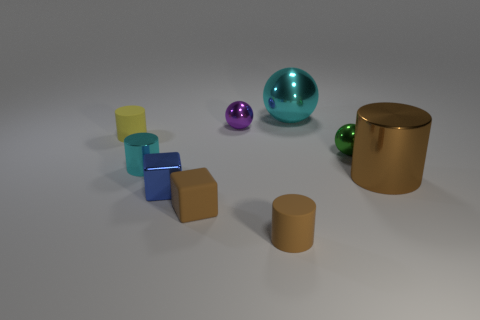How big is the brown rubber thing to the right of the brown rubber object that is on the left side of the brown cylinder on the left side of the large metallic cylinder?
Your answer should be very brief. Small. Is the number of big spheres that are to the right of the tiny green thing less than the number of cyan spheres that are to the right of the metallic block?
Ensure brevity in your answer.  Yes. How many green balls are the same material as the big cyan ball?
Provide a short and direct response. 1. There is a big object that is in front of the ball that is in front of the small purple object; are there any brown metal cylinders behind it?
Offer a terse response. No. There is a purple thing that is the same material as the tiny cyan cylinder; what shape is it?
Your answer should be compact. Sphere. Are there more things than green objects?
Offer a terse response. Yes. Does the tiny green thing have the same shape as the tiny matte thing that is behind the green metallic thing?
Make the answer very short. No. What is the material of the brown block?
Your response must be concise. Rubber. There is a small rubber thing left of the tiny brown object that is behind the cylinder in front of the brown block; what is its color?
Give a very brief answer. Yellow. There is a large object that is the same shape as the small purple thing; what is it made of?
Your answer should be compact. Metal. 